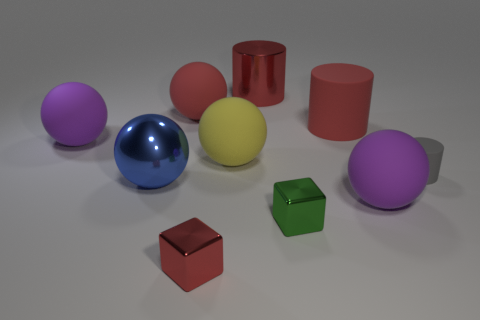Does the tiny cylinder have the same color as the shiny block left of the metal cylinder?
Provide a short and direct response. No. Are there more small rubber cylinders than large gray rubber blocks?
Make the answer very short. Yes. What is the size of the red thing that is the same shape as the blue object?
Offer a very short reply. Large. Do the big yellow ball and the purple object left of the small green block have the same material?
Offer a terse response. Yes. What number of objects are gray cylinders or tiny red blocks?
Ensure brevity in your answer.  2. Is the size of the purple sphere that is on the left side of the big rubber cylinder the same as the matte cylinder that is on the right side of the large rubber cylinder?
Provide a short and direct response. No. How many spheres are large red metal objects or purple matte objects?
Provide a short and direct response. 2. Are there any yellow matte balls?
Offer a very short reply. Yes. Do the big matte cylinder and the metal cylinder have the same color?
Ensure brevity in your answer.  Yes. What number of things are either large purple rubber spheres that are on the right side of the tiny red shiny cube or blue things?
Give a very brief answer. 2. 